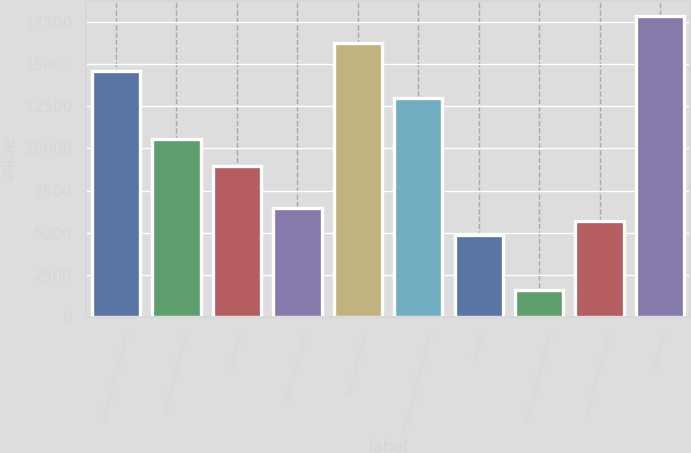<chart> <loc_0><loc_0><loc_500><loc_500><bar_chart><fcel>Cash and cash equivalents<fcel>Accounts receivable net<fcel>Inventories<fcel>Other current assets<fcel>Total current assets<fcel>Property plant and equipment<fcel>Goodwill<fcel>Other intangible assets net<fcel>Other non-current assets<fcel>Total assets<nl><fcel>14610.8<fcel>10552.8<fcel>8929.6<fcel>6494.8<fcel>16234<fcel>12987.6<fcel>4871.6<fcel>1625.2<fcel>5683.2<fcel>17857.2<nl></chart> 